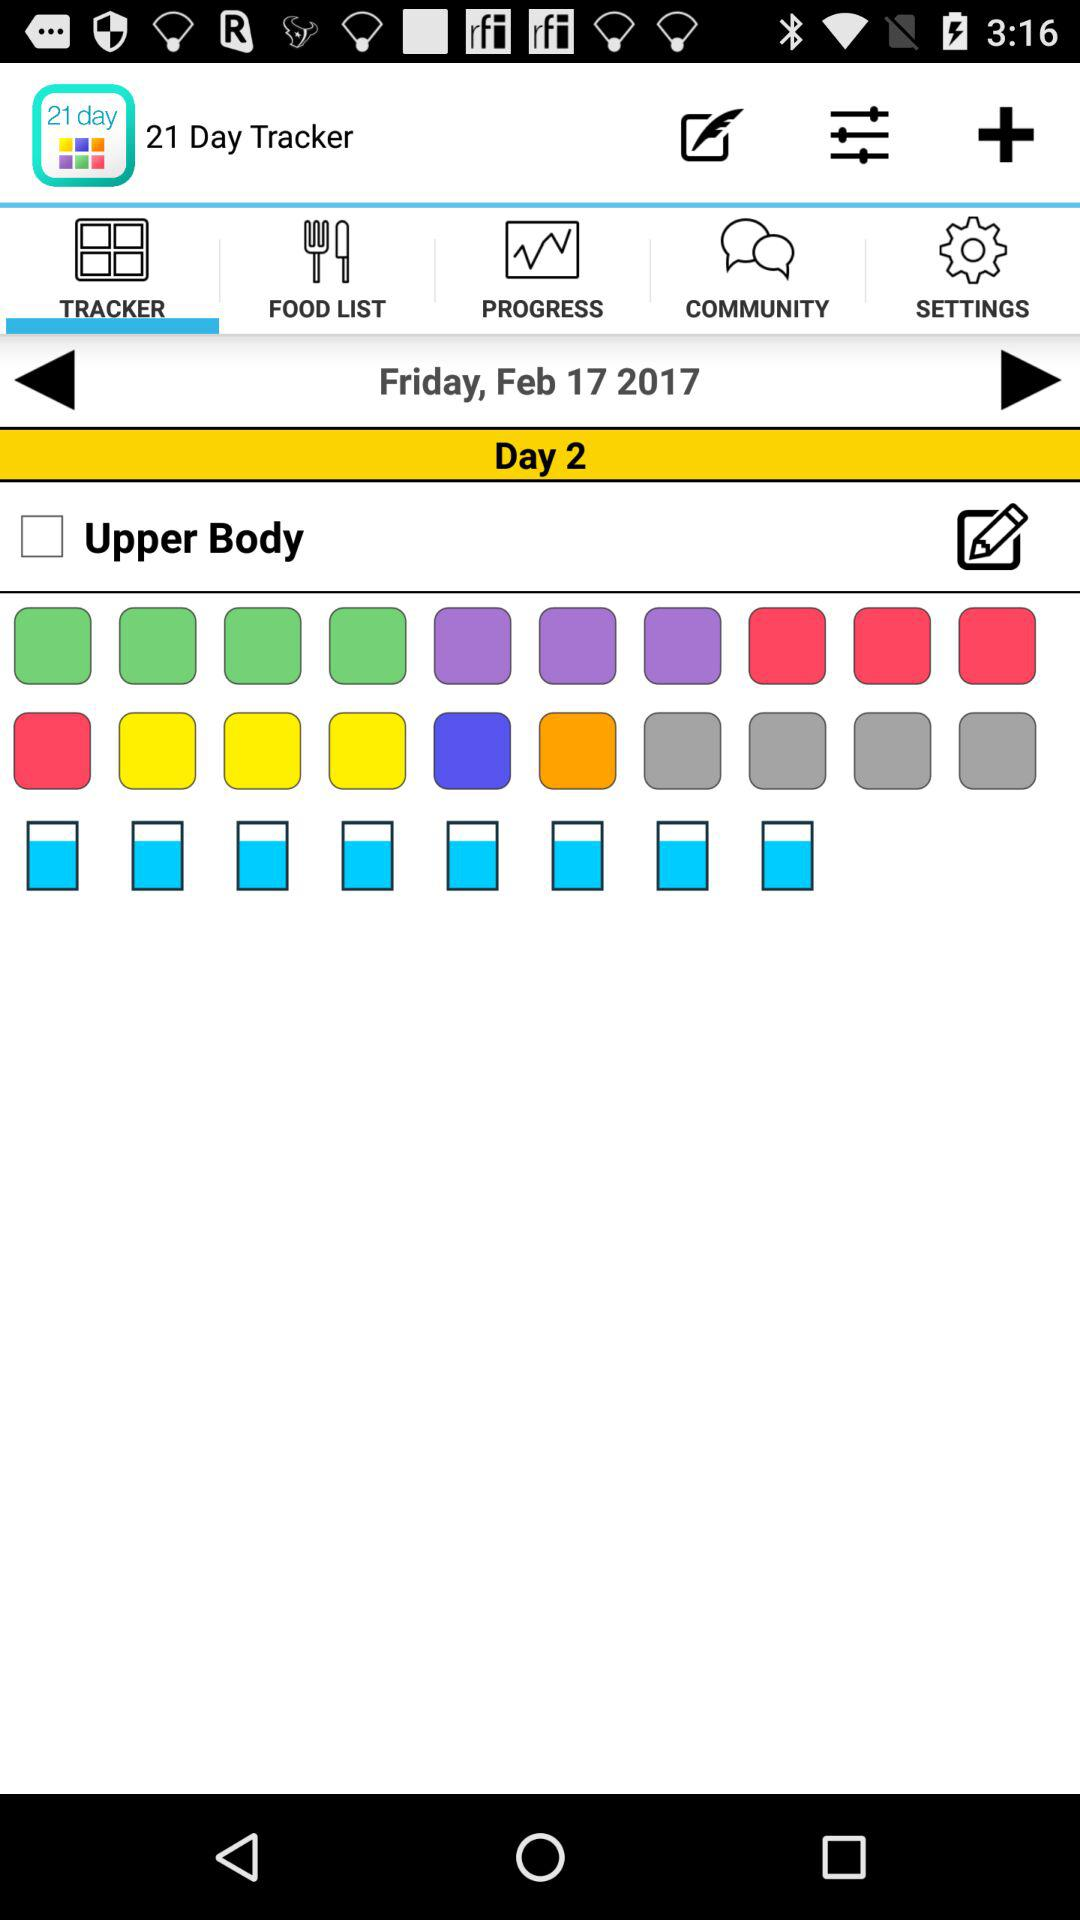How much progress has been made?
When the provided information is insufficient, respond with <no answer>. <no answer> 